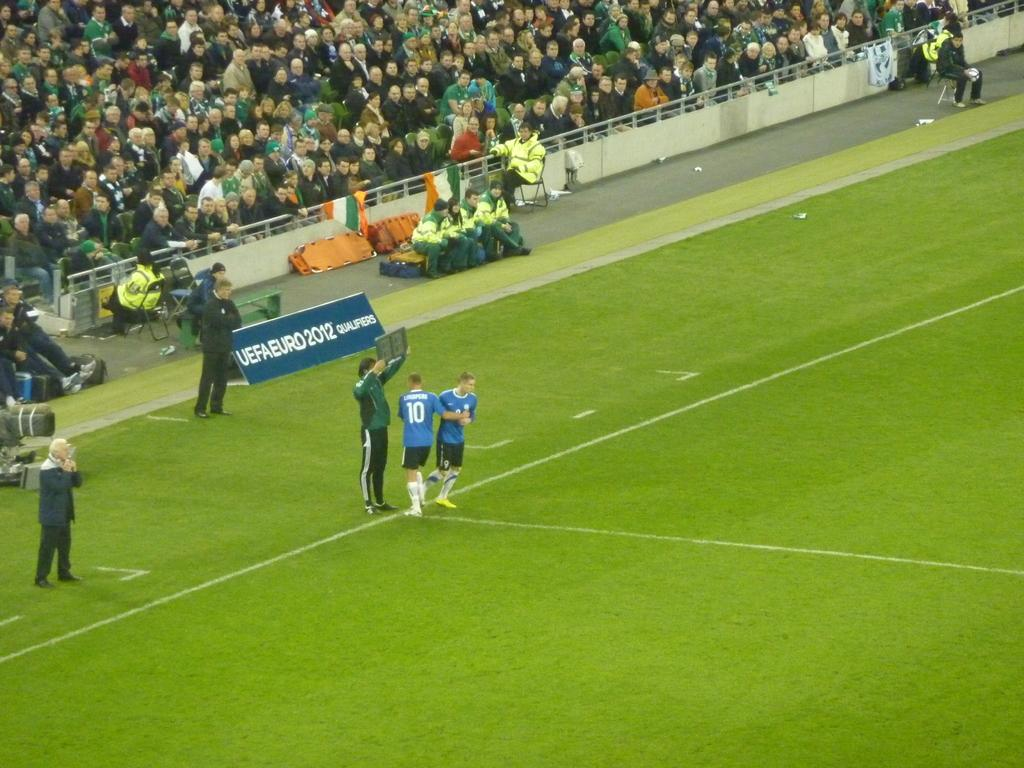What is happening in the center of the image? There are people standing in the center of the image. What is happening in the background of the image? There is a crowd sitting in the background of the image. What is the purpose of the fence in the image? The fence is visible in the image, but its purpose is not explicitly stated. What can be seen flying or waving in the image? Flags are present in the image. Where is the lunchroom located in the image? There is no mention of a lunchroom or a shelf in the image. What type of shoes are the people wearing in the image? The image does not show the shoes the people are wearing. 